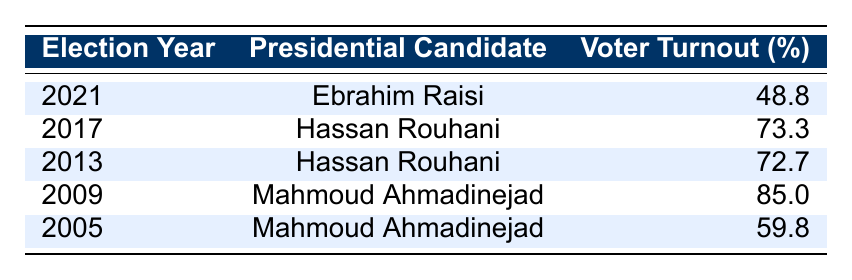What was the voter turnout percentage in the 2021 presidential election? The table shows that the voter turnout percentage in the 2021 presidential election was 48.8%.
Answer: 48.8% Which candidate had the highest voter turnout, and what was the percentage? According to the table, Mahmoud Ahmadinejad had the highest voter turnout at 85.0% during the 2009 election.
Answer: Mahmoud Ahmadinejad, 85.0% What is the voter turnout percentage in 2017? The table indicates that the voter turnout percentage in the 2017 election was 73.3%.
Answer: 73.3% Calculate the average voter turnout percentage over the last five elections. First, we sum the percentages: 48.8 + 73.3 + 72.7 + 85.0 + 59.8 = 339.6. Then, we divide by the number of elections: 339.6 / 5 = 67.92.
Answer: 67.92% True or False: The voter turnout percentage increased from 2005 to 2009. By examining the years, we see the percentages were 59.8% in 2005 and 85.0% in 2009, indicating an increase. Therefore, the statement is True.
Answer: True Which two elections had the closest voter turnout percentages? The closest voter turnout percentages can be found between the 2013 (72.7%) and 2017 (73.3%) elections, which differ by only 0.6%.
Answer: 2013 and 2017 How did the voter turnout change from 2009 to 2021? In 2009, the voter turnout was 85.0%, and in 2021 it dropped to 48.8%. The difference is 85.0% - 48.8% = 36.2%, indicating a significant decrease.
Answer: Decreased by 36.2% What percentage of the elections had a turnout above 70%? The elections in 2009 (85.0%), 2013 (72.7%), and 2017 (73.3%) had turnouts above 70%. This accounts for 3 out of 5 elections, which is 60%.
Answer: 60% Was the voter turnout generally higher for Mahmoud Ahmadinejad compared to Ebrahim Raisi? Mahmoud Ahmadinejad had turnout percentages of 85.0% in 2009 and 59.8% in 2005, while Ebrahim Raisi had 48.8% in 2021. Both elections show Ahmadinejad's percentages were higher than Raisi's. Therefore, the statement is true.
Answer: True How much lower was the turnout in 2021 compared to the highest turnout in the table? The highest turnout was 85.0% in 2009, and the turnout in 2021 was 48.8%. The difference is 85.0% - 48.8% = 36.2%.
Answer: 36.2% 